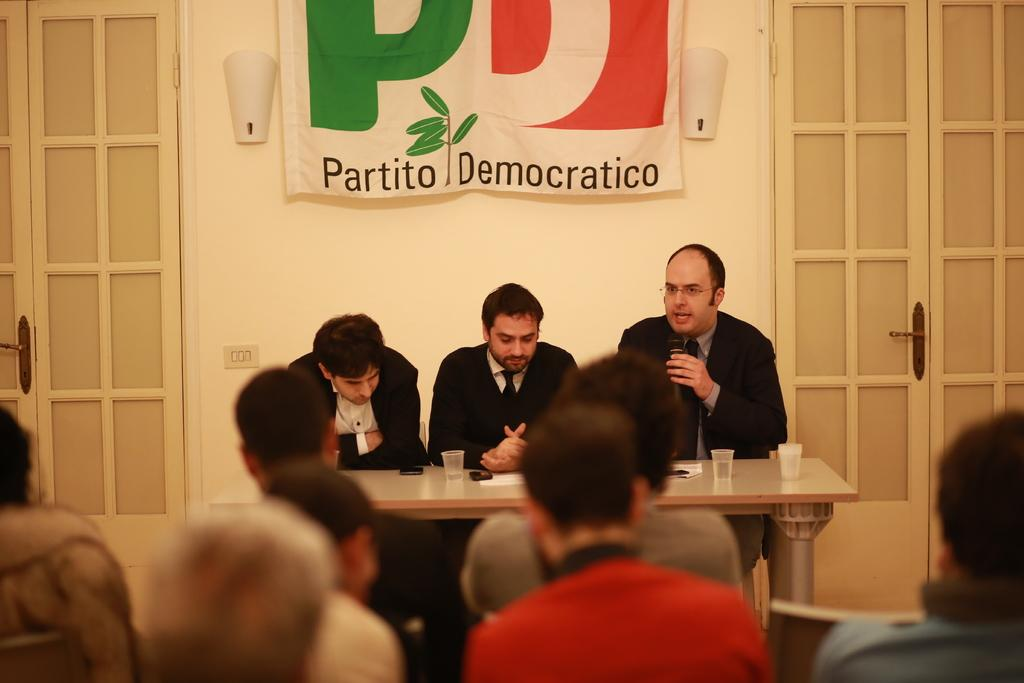How many persons are sitting on chairs in the image? There are three persons sitting on chairs in the image. What is present on the table in the image? There are glasses on the table in the image. What architectural features can be seen in the image? There are doors and a wall visible in the image. What additional object is present in the image? There is a banner in the image. Are there any other people visible in the image besides the three sitting on chairs? Yes, there are additional persons visible in the image. What type of wrist treatment is being performed on the person in the image? There is no wrist treatment being performed in the image; it features people sitting on chairs and other objects. Is there a quilt visible in the image? No, there is no quilt present in the image. 